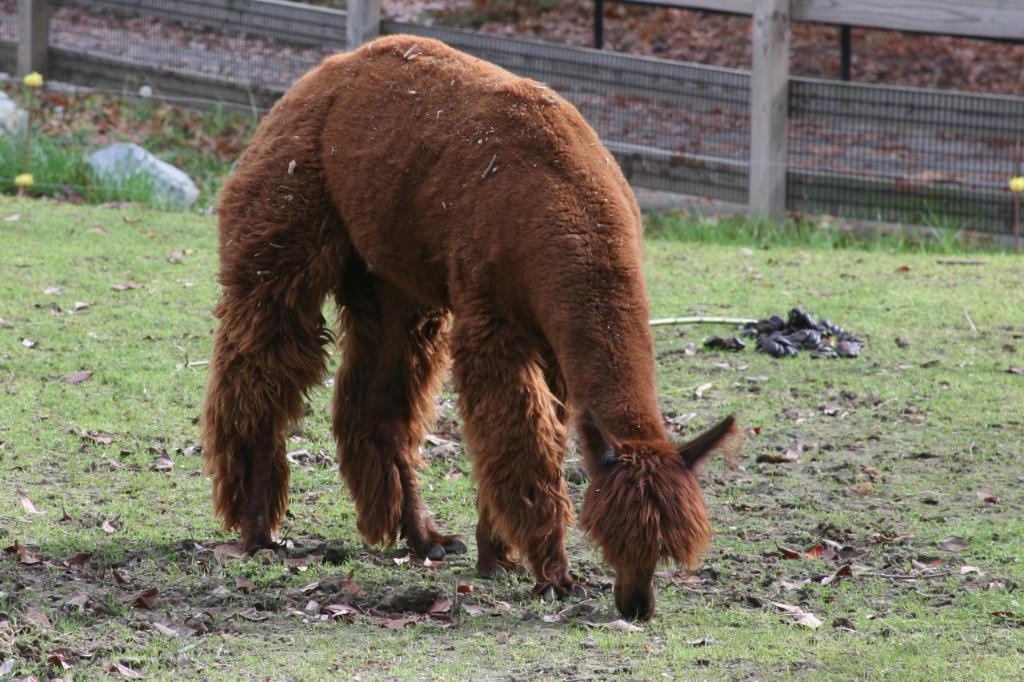What type of animal can be seen in the image? There is an animal in the image. What is the animal doing in the image? The animal is grazing grass from the ground. What is located behind the animal in the image? There is a fencing behind the animal. What type of stamp can be seen on the animal's forehead in the image? There is no stamp visible on the animal's forehead in the image. What type of robin can be seen in the image? There is no robin present in the image; it features an animal grazing grass. 